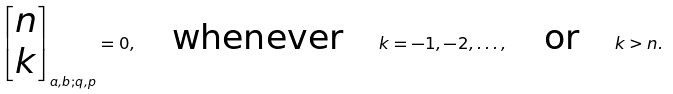<formula> <loc_0><loc_0><loc_500><loc_500>\begin{bmatrix} n \\ k \end{bmatrix} _ { a , b ; q , p } = 0 , \quad \text {whenever} \quad k = - 1 , - 2 , \dots , \quad \text {or} \quad k > n .</formula> 